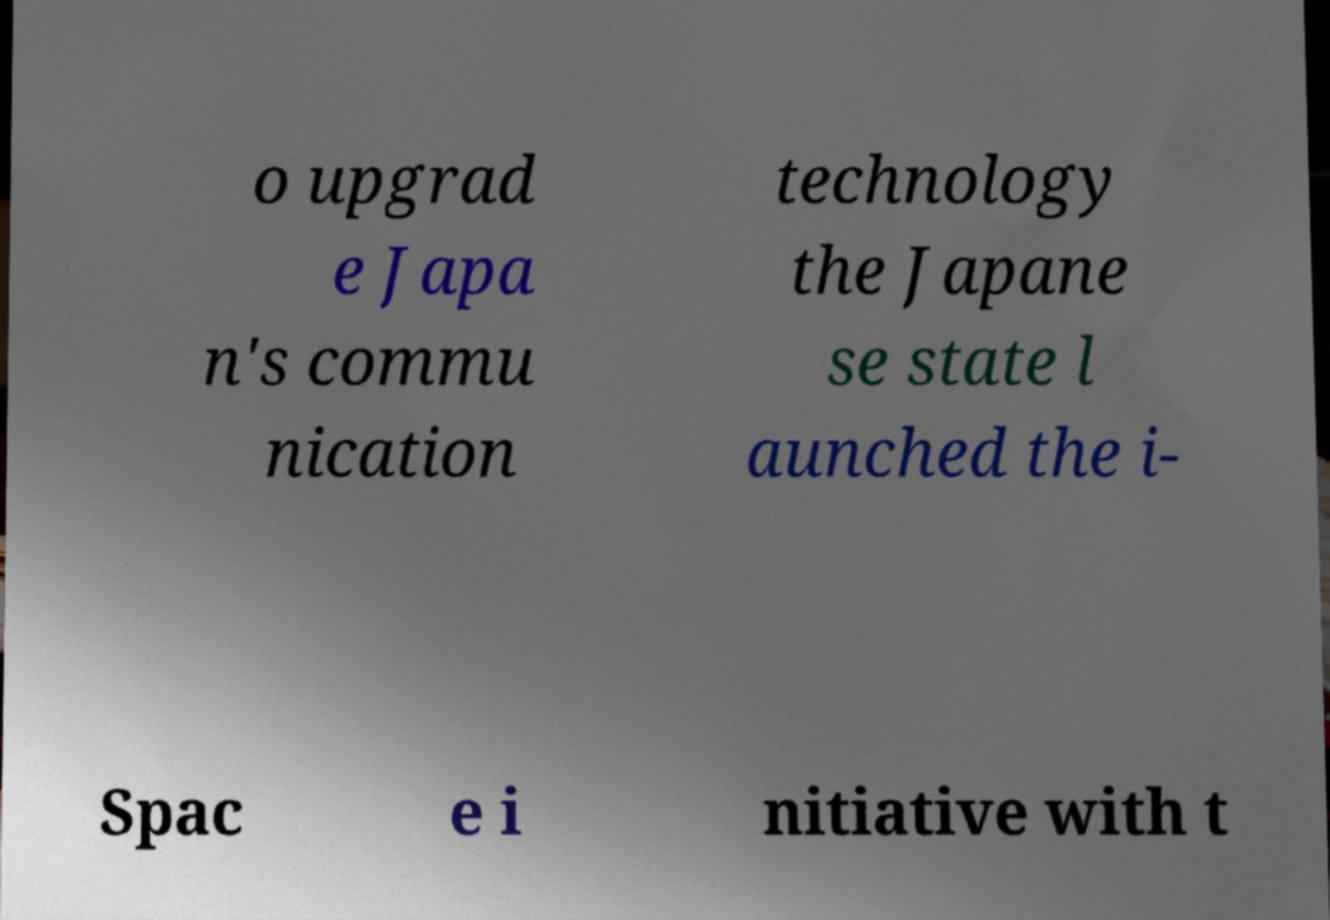For documentation purposes, I need the text within this image transcribed. Could you provide that? o upgrad e Japa n's commu nication technology the Japane se state l aunched the i- Spac e i nitiative with t 